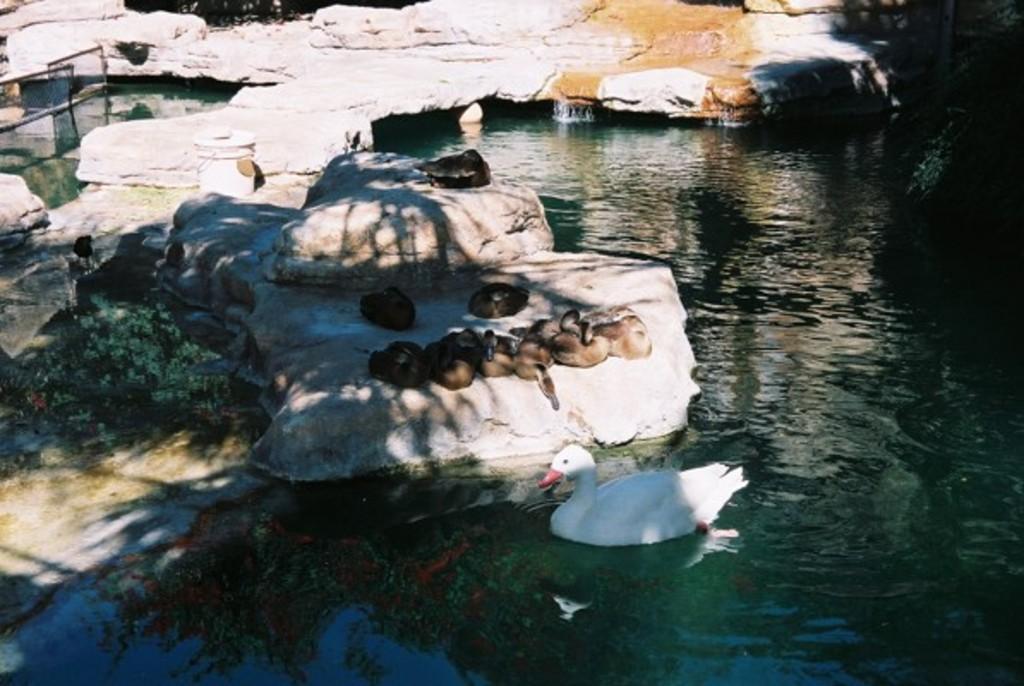In one or two sentences, can you explain what this image depicts? In this image on the right there is water body. On the stones there are birds here. There is a duck. There are few plants here. This is boundary. 